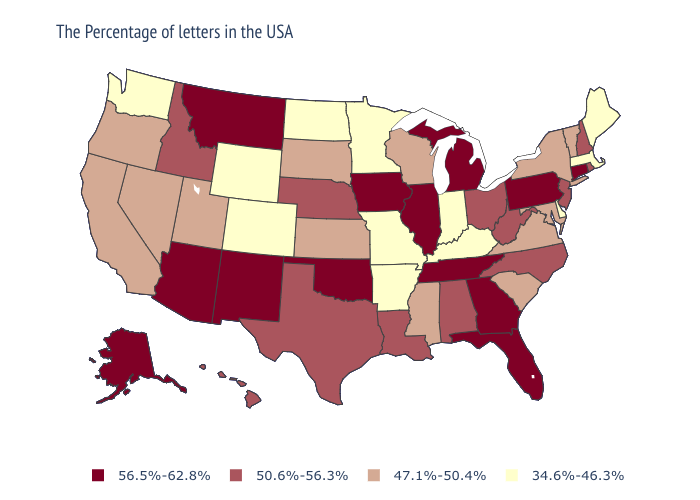Name the states that have a value in the range 56.5%-62.8%?
Quick response, please. Connecticut, Pennsylvania, Florida, Georgia, Michigan, Tennessee, Illinois, Iowa, Oklahoma, New Mexico, Montana, Arizona, Alaska. Name the states that have a value in the range 56.5%-62.8%?
Short answer required. Connecticut, Pennsylvania, Florida, Georgia, Michigan, Tennessee, Illinois, Iowa, Oklahoma, New Mexico, Montana, Arizona, Alaska. What is the lowest value in the USA?
Give a very brief answer. 34.6%-46.3%. Does Colorado have the highest value in the West?
Quick response, please. No. Which states have the highest value in the USA?
Concise answer only. Connecticut, Pennsylvania, Florida, Georgia, Michigan, Tennessee, Illinois, Iowa, Oklahoma, New Mexico, Montana, Arizona, Alaska. What is the value of Missouri?
Answer briefly. 34.6%-46.3%. Among the states that border Wisconsin , does Michigan have the lowest value?
Be succinct. No. Name the states that have a value in the range 47.1%-50.4%?
Short answer required. Vermont, New York, Maryland, Virginia, South Carolina, Wisconsin, Mississippi, Kansas, South Dakota, Utah, Nevada, California, Oregon. Does the first symbol in the legend represent the smallest category?
Answer briefly. No. Name the states that have a value in the range 34.6%-46.3%?
Be succinct. Maine, Massachusetts, Delaware, Kentucky, Indiana, Missouri, Arkansas, Minnesota, North Dakota, Wyoming, Colorado, Washington. What is the value of Maryland?
Keep it brief. 47.1%-50.4%. Does Kentucky have the lowest value in the South?
Be succinct. Yes. What is the highest value in the South ?
Give a very brief answer. 56.5%-62.8%. Is the legend a continuous bar?
Concise answer only. No. What is the lowest value in the USA?
Give a very brief answer. 34.6%-46.3%. 